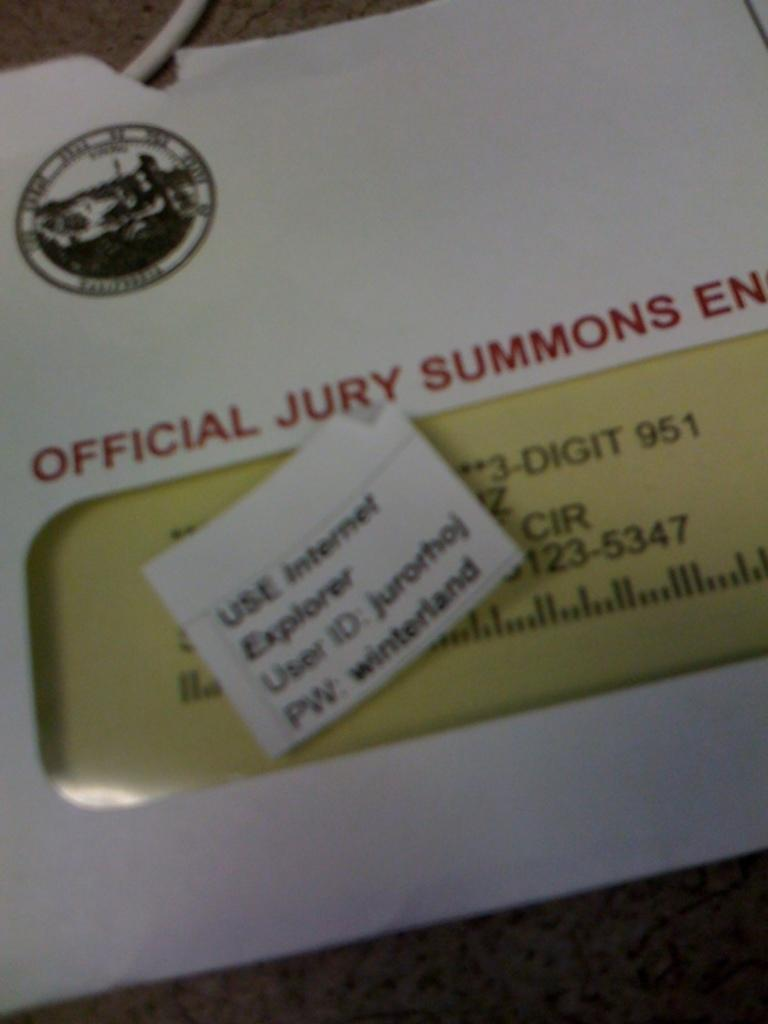<image>
Provide a brief description of the given image. The writing on the envelope indicates it contains a jury summons. 